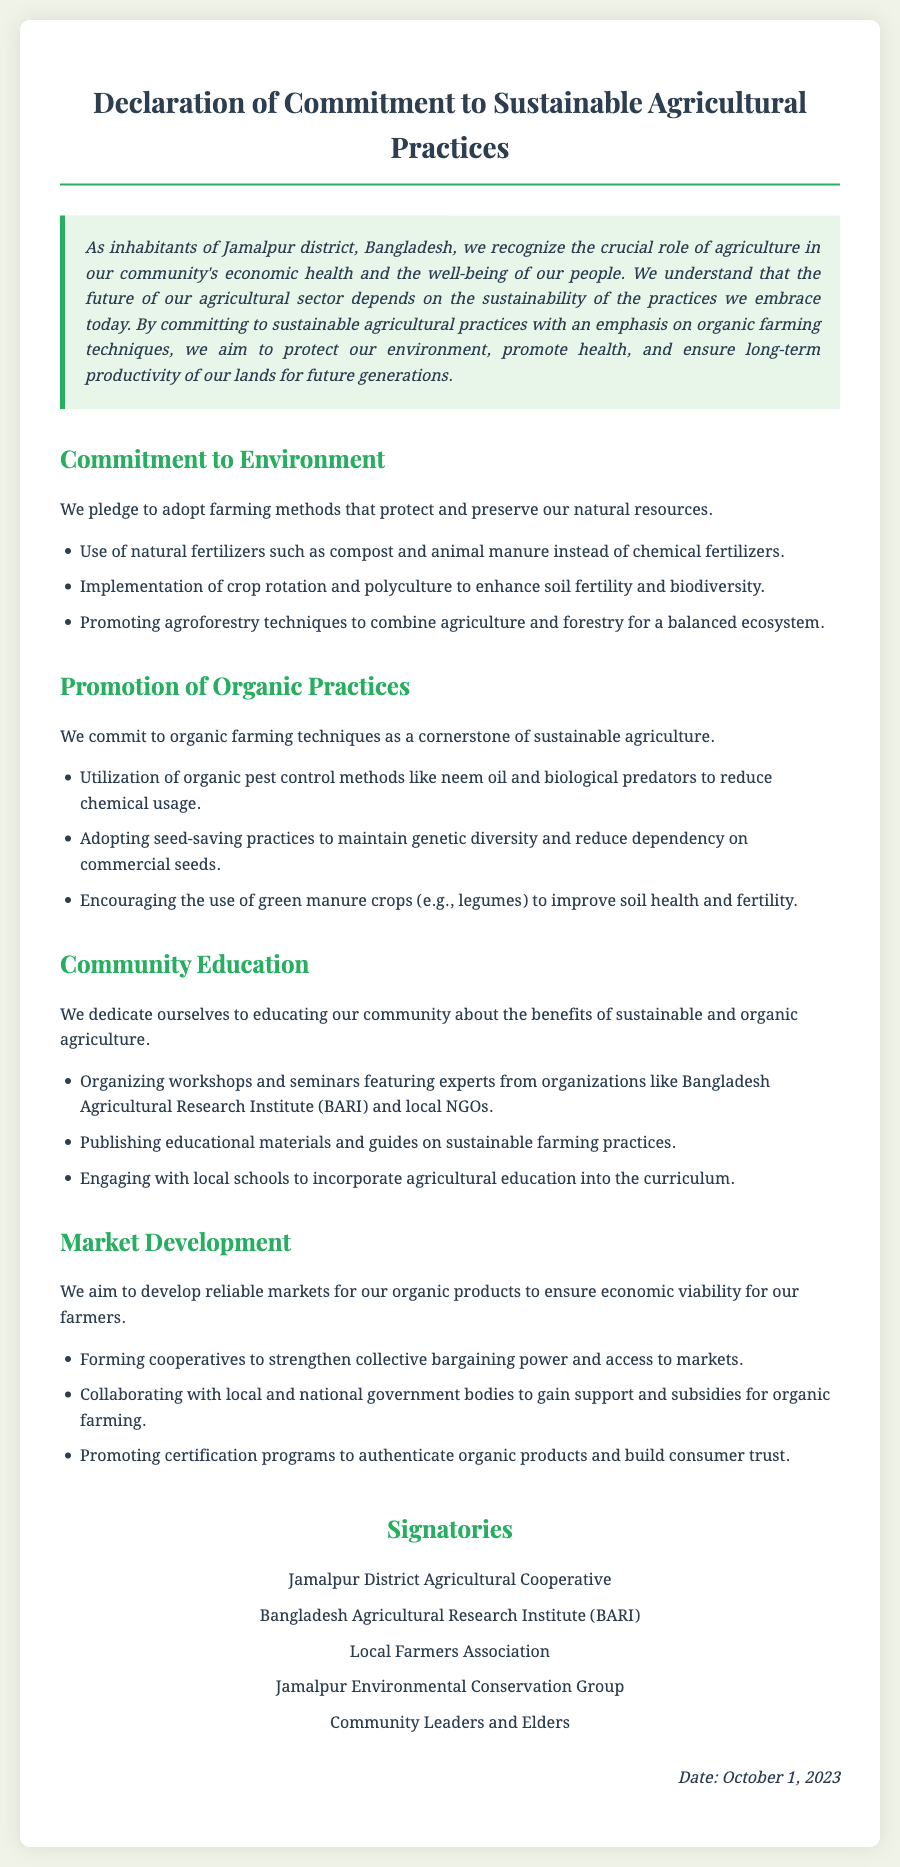what is the title of the declaration? The title is presented at the top of the document as the main heading.
Answer: Declaration of Commitment to Sustainable Agricultural Practices who is committed to promoting organic practices? The organizations and groups listed under signatories demonstrate commitment to organic practices.
Answer: Jamalpur District Agricultural Cooperative when was this declaration signed? The date is mentioned in the footer of the document.
Answer: October 1, 2023 what farming method is emphasized to protect natural resources? This question seeks to highlight a specific pledge mentioned in the document.
Answer: Natural fertilizers which organization is mentioned as engaging with local schools? The document lists entities that will engage in educational activities.
Answer: Local Farmers Association what is included in the community education section? This question requires linking elements of the community education commitment.
Answer: Workshops and seminars how many signatories are listed? The number of signatories is the count of organizations mentioned in the signatories section.
Answer: Five what type of markets are aimed to be developed? This question focuses on the objective related to the market in the document.
Answer: Reliable markets for organic products which technique is suggested to enhance soil fertility? The document provides specific techniques to improve soil health.
Answer: Crop rotation and polyculture 